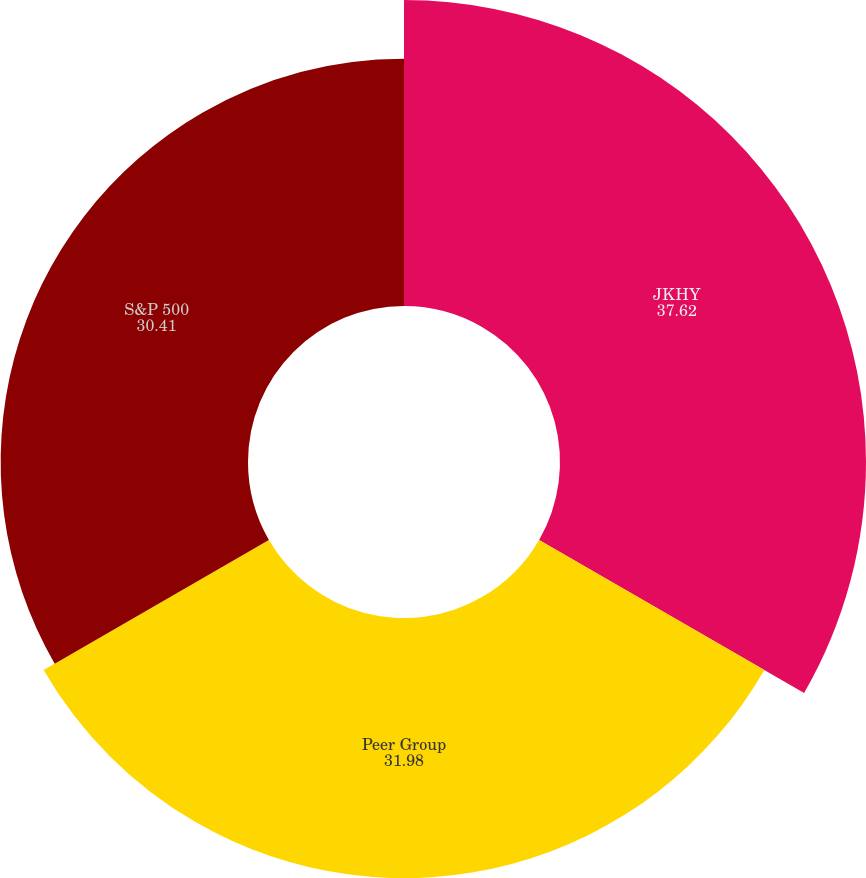Convert chart. <chart><loc_0><loc_0><loc_500><loc_500><pie_chart><fcel>JKHY<fcel>Peer Group<fcel>S&P 500<nl><fcel>37.62%<fcel>31.98%<fcel>30.41%<nl></chart> 